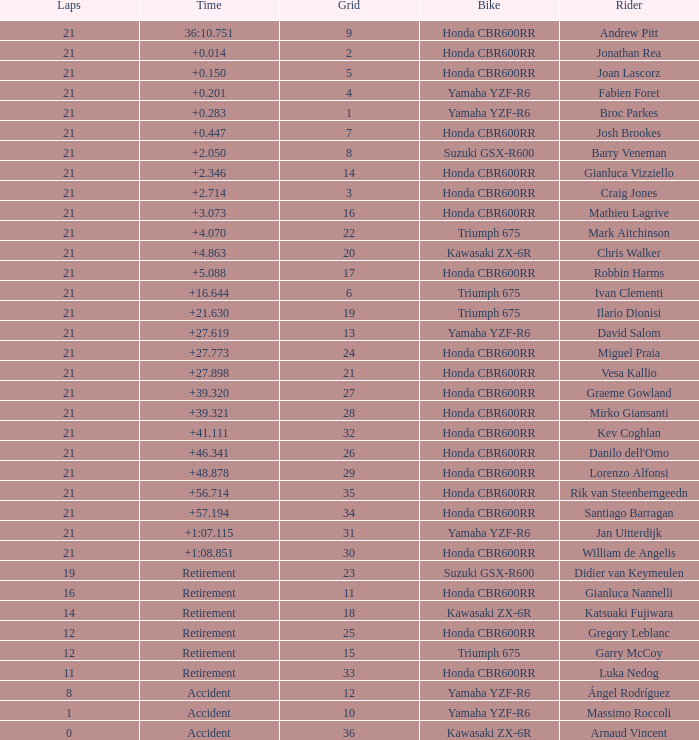What is the total of laps run by the driver with a grid under 17 and a time of +5.088? None. 